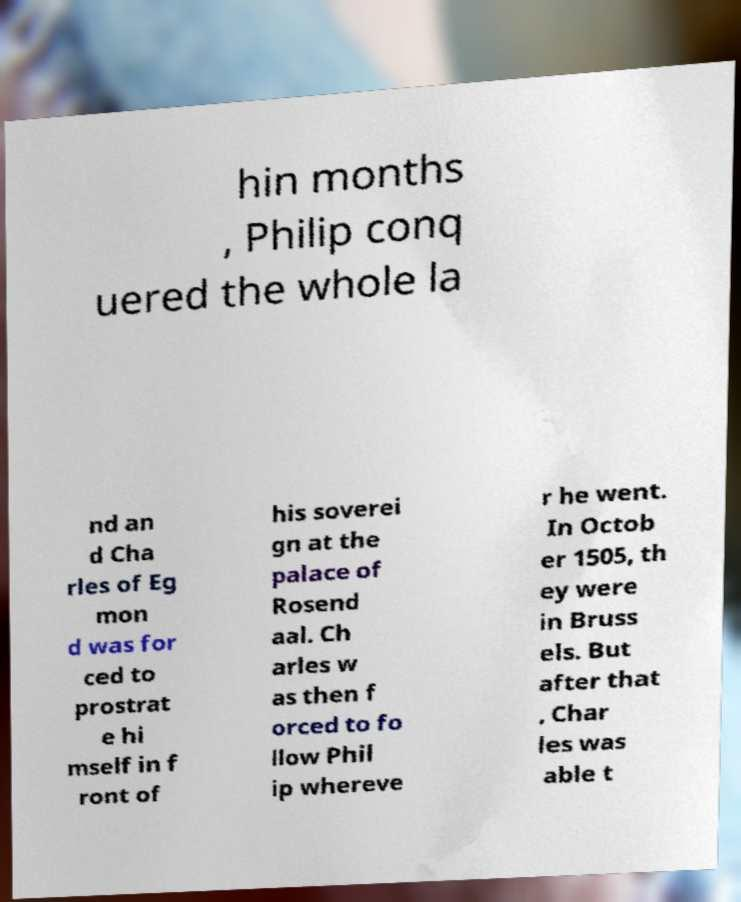Could you extract and type out the text from this image? hin months , Philip conq uered the whole la nd an d Cha rles of Eg mon d was for ced to prostrat e hi mself in f ront of his soverei gn at the palace of Rosend aal. Ch arles w as then f orced to fo llow Phil ip whereve r he went. In Octob er 1505, th ey were in Bruss els. But after that , Char les was able t 